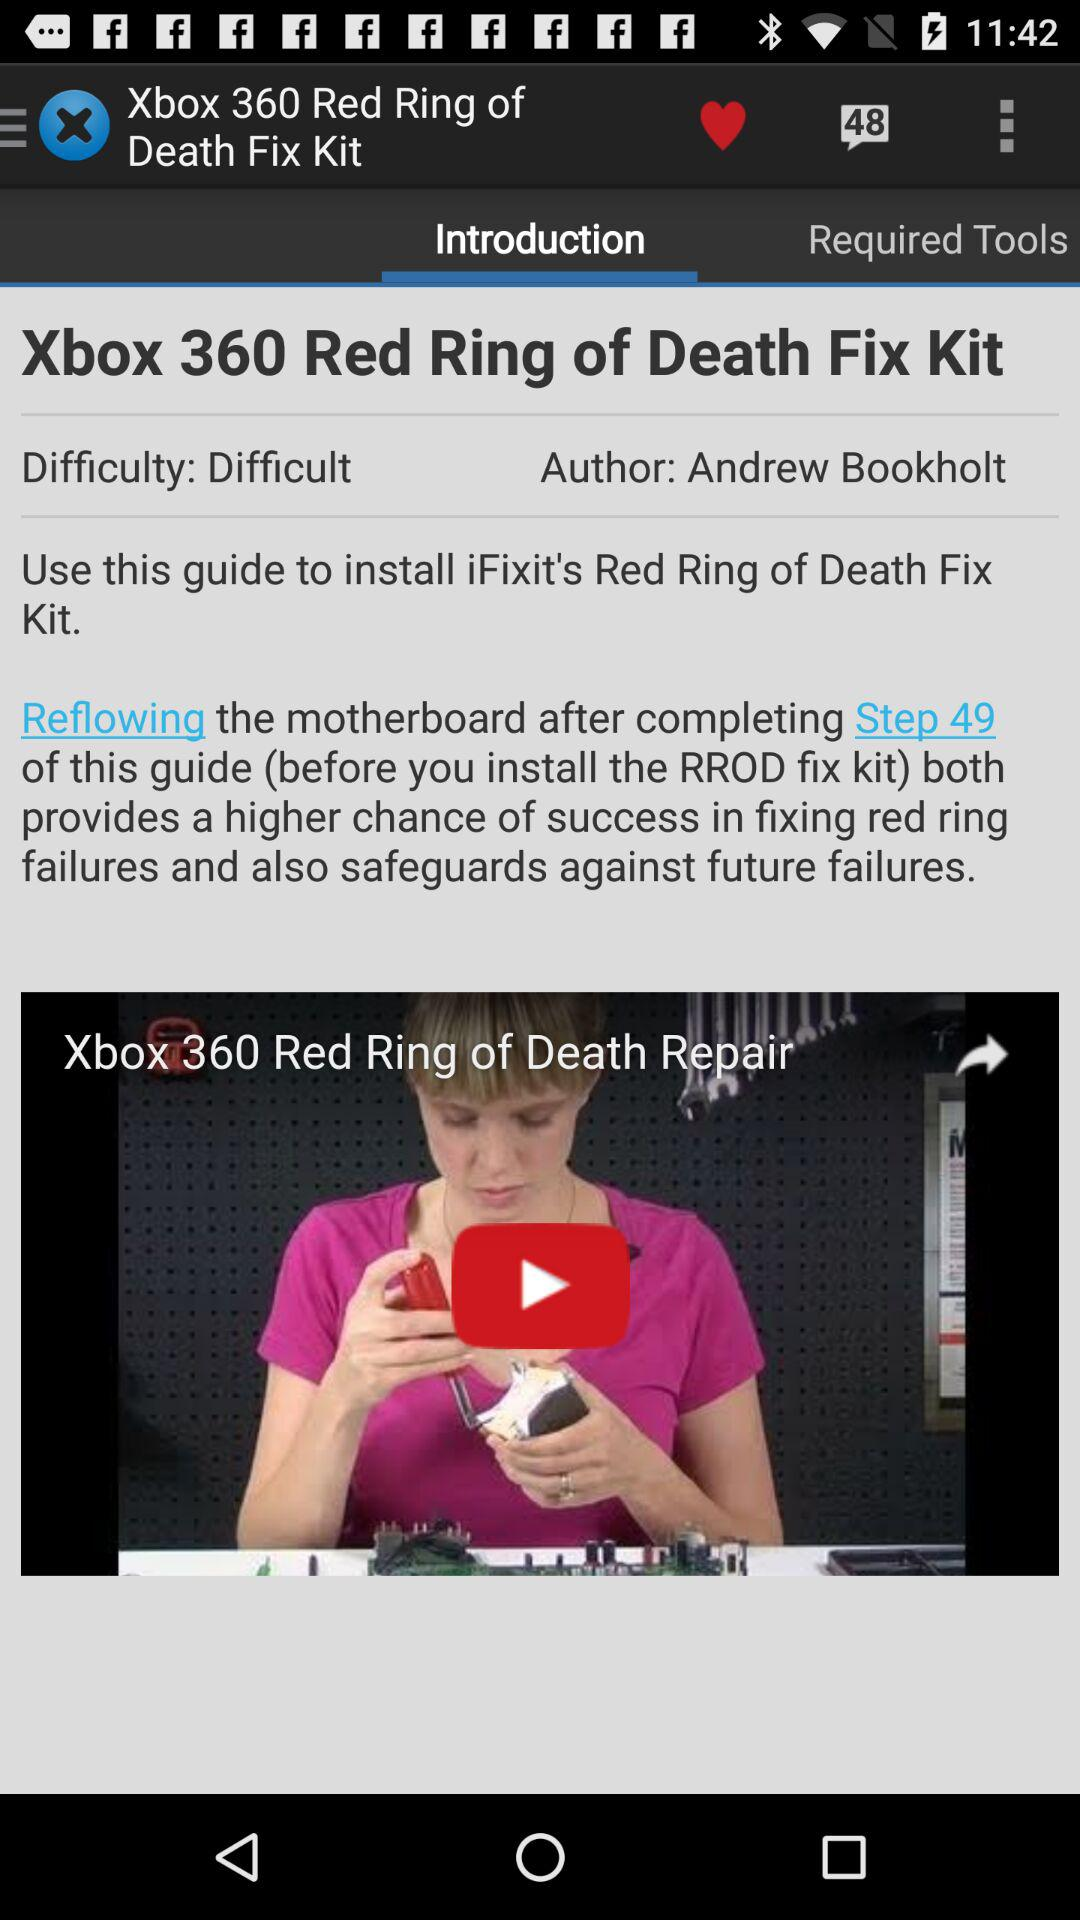What is the difficulty level? The difficulty level is difficult. 